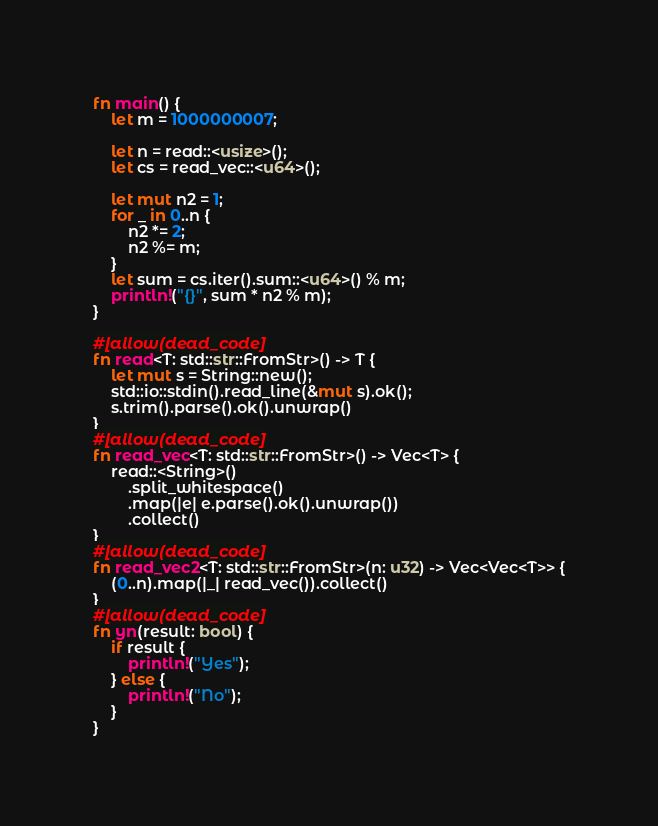<code> <loc_0><loc_0><loc_500><loc_500><_Rust_>fn main() {
    let m = 1000000007;

    let n = read::<usize>();
    let cs = read_vec::<u64>();

    let mut n2 = 1;
    for _ in 0..n {
        n2 *= 2;
        n2 %= m;
    }
    let sum = cs.iter().sum::<u64>() % m;
    println!("{}", sum * n2 % m);
}

#[allow(dead_code)]
fn read<T: std::str::FromStr>() -> T {
    let mut s = String::new();
    std::io::stdin().read_line(&mut s).ok();
    s.trim().parse().ok().unwrap()
}
#[allow(dead_code)]
fn read_vec<T: std::str::FromStr>() -> Vec<T> {
    read::<String>()
        .split_whitespace()
        .map(|e| e.parse().ok().unwrap())
        .collect()
}
#[allow(dead_code)]
fn read_vec2<T: std::str::FromStr>(n: u32) -> Vec<Vec<T>> {
    (0..n).map(|_| read_vec()).collect()
}
#[allow(dead_code)]
fn yn(result: bool) {
    if result {
        println!("Yes");
    } else {
        println!("No");
    }
}
</code> 